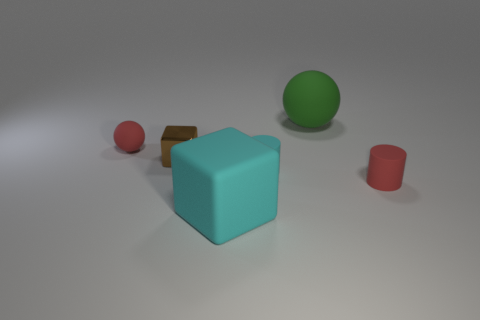There is a tiny red matte object on the left side of the green matte object; is its shape the same as the large object behind the big matte block?
Offer a very short reply. Yes. There is a small cylinder to the right of the cyan matte cylinder; what is it made of?
Keep it short and to the point. Rubber. What size is the matte cylinder that is the same color as the large cube?
Your response must be concise. Small. What number of objects are either cyan matte cylinders that are left of the big rubber sphere or large objects?
Your answer should be compact. 3. Is the number of small cylinders to the left of the tiny red matte sphere the same as the number of big red matte objects?
Your answer should be very brief. Yes. Does the metallic thing have the same size as the red sphere?
Make the answer very short. Yes. What color is the matte sphere that is the same size as the cyan rubber cylinder?
Offer a terse response. Red. Is the size of the shiny cube the same as the ball that is left of the green rubber ball?
Provide a succinct answer. Yes. How many objects are the same color as the tiny rubber sphere?
Give a very brief answer. 1. How many objects are either large blue cylinders or spheres to the right of the brown cube?
Make the answer very short. 1. 